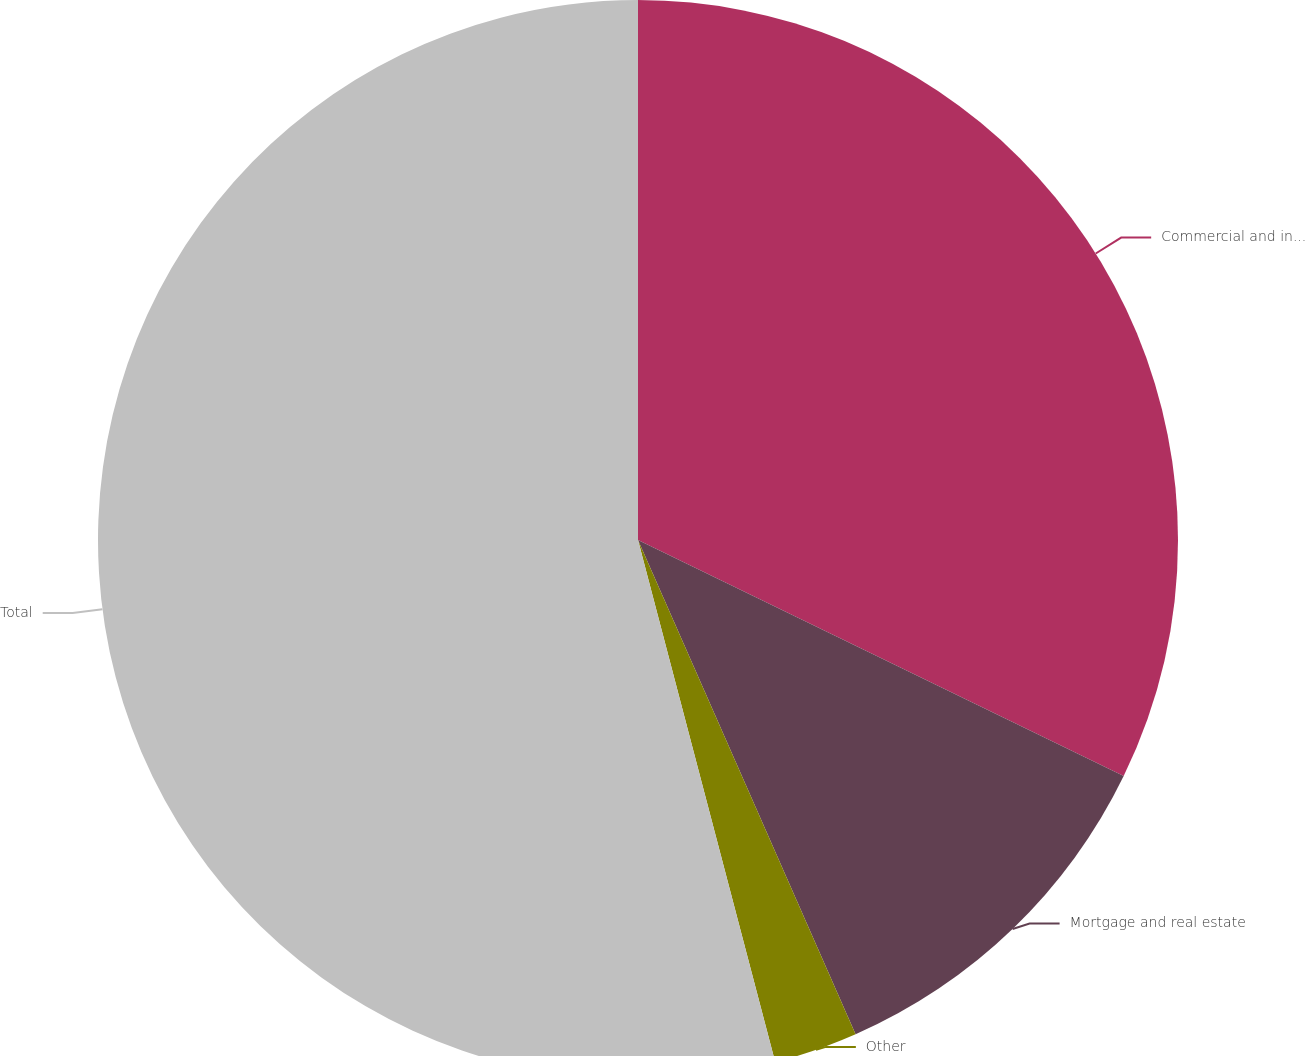Convert chart. <chart><loc_0><loc_0><loc_500><loc_500><pie_chart><fcel>Commercial and industrial<fcel>Mortgage and real estate<fcel>Other<fcel>Total<nl><fcel>32.2%<fcel>11.2%<fcel>2.51%<fcel>54.09%<nl></chart> 